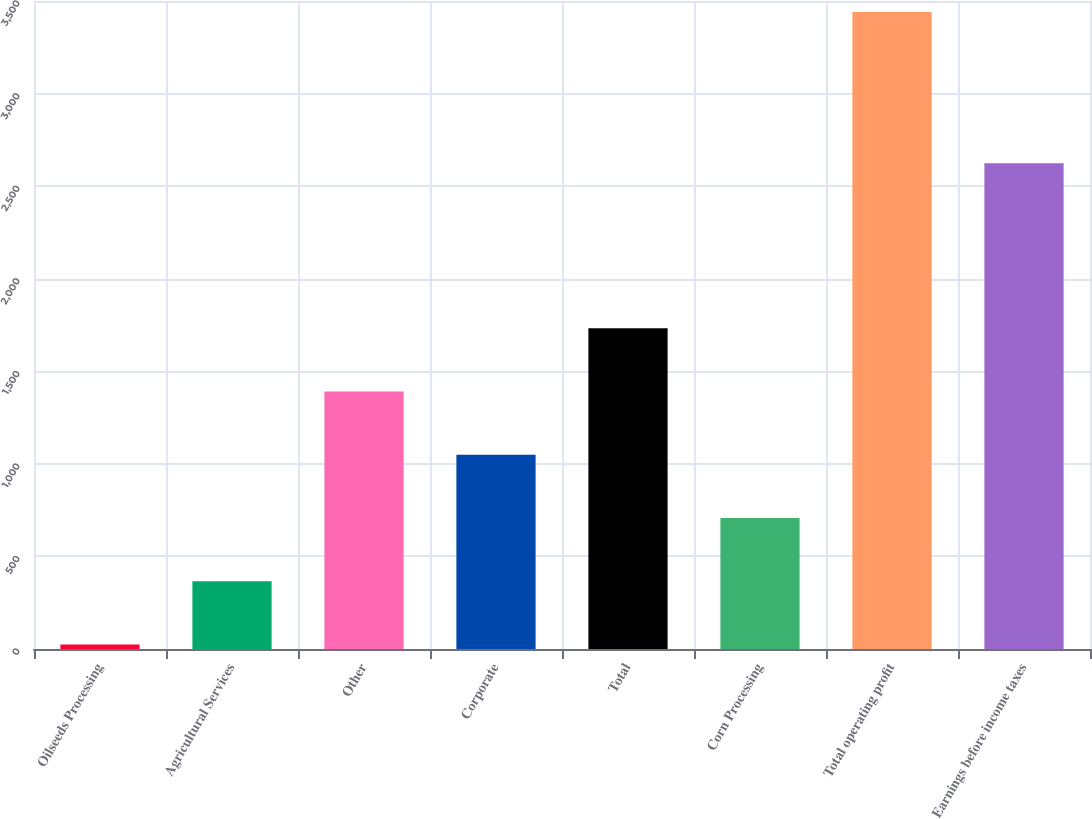Convert chart to OTSL. <chart><loc_0><loc_0><loc_500><loc_500><bar_chart><fcel>Oilseeds Processing<fcel>Agricultural Services<fcel>Other<fcel>Corporate<fcel>Total<fcel>Corn Processing<fcel>Total operating profit<fcel>Earnings before income taxes<nl><fcel>24<fcel>365.7<fcel>1390.8<fcel>1049.1<fcel>1732.5<fcel>707.4<fcel>3441<fcel>2624<nl></chart> 